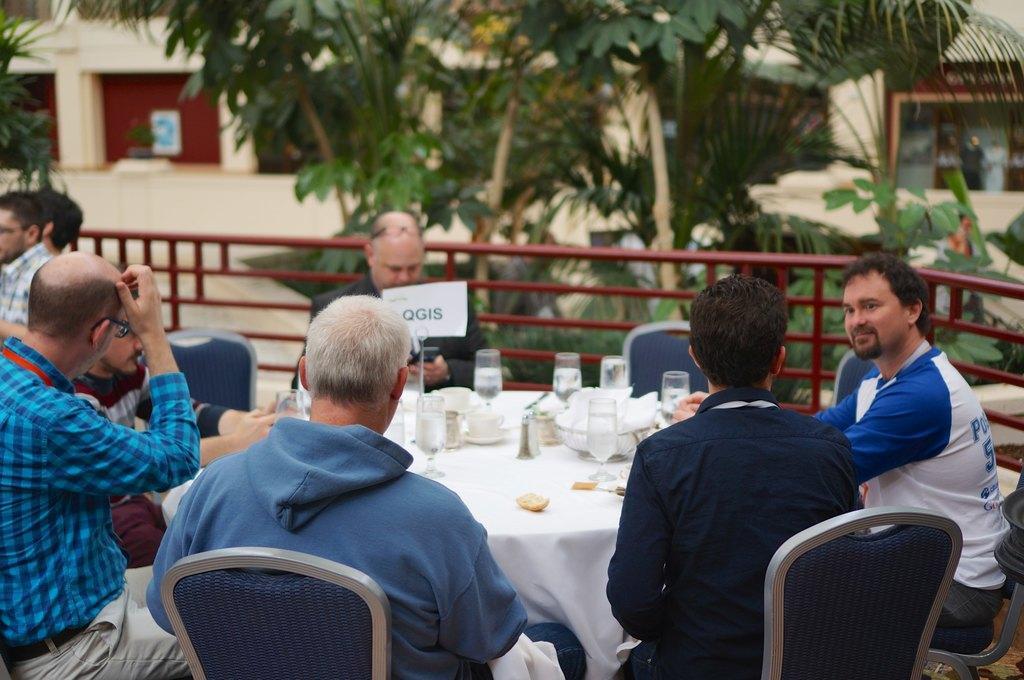Can you describe this image briefly? This is a image out side of a building and there are the person sitting around the table ,on the table there are the bowls and glasses kept on the table. an there is a fence with red color ,after the fence there are some threes visible and there is a building visible on the back ground. 